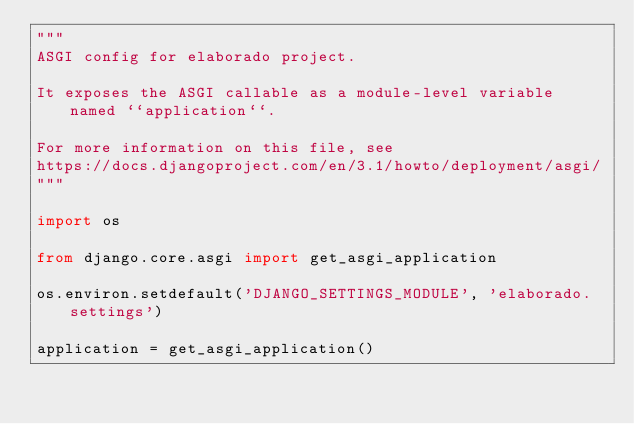Convert code to text. <code><loc_0><loc_0><loc_500><loc_500><_Python_>"""
ASGI config for elaborado project.

It exposes the ASGI callable as a module-level variable named ``application``.

For more information on this file, see
https://docs.djangoproject.com/en/3.1/howto/deployment/asgi/
"""

import os

from django.core.asgi import get_asgi_application

os.environ.setdefault('DJANGO_SETTINGS_MODULE', 'elaborado.settings')

application = get_asgi_application()
</code> 